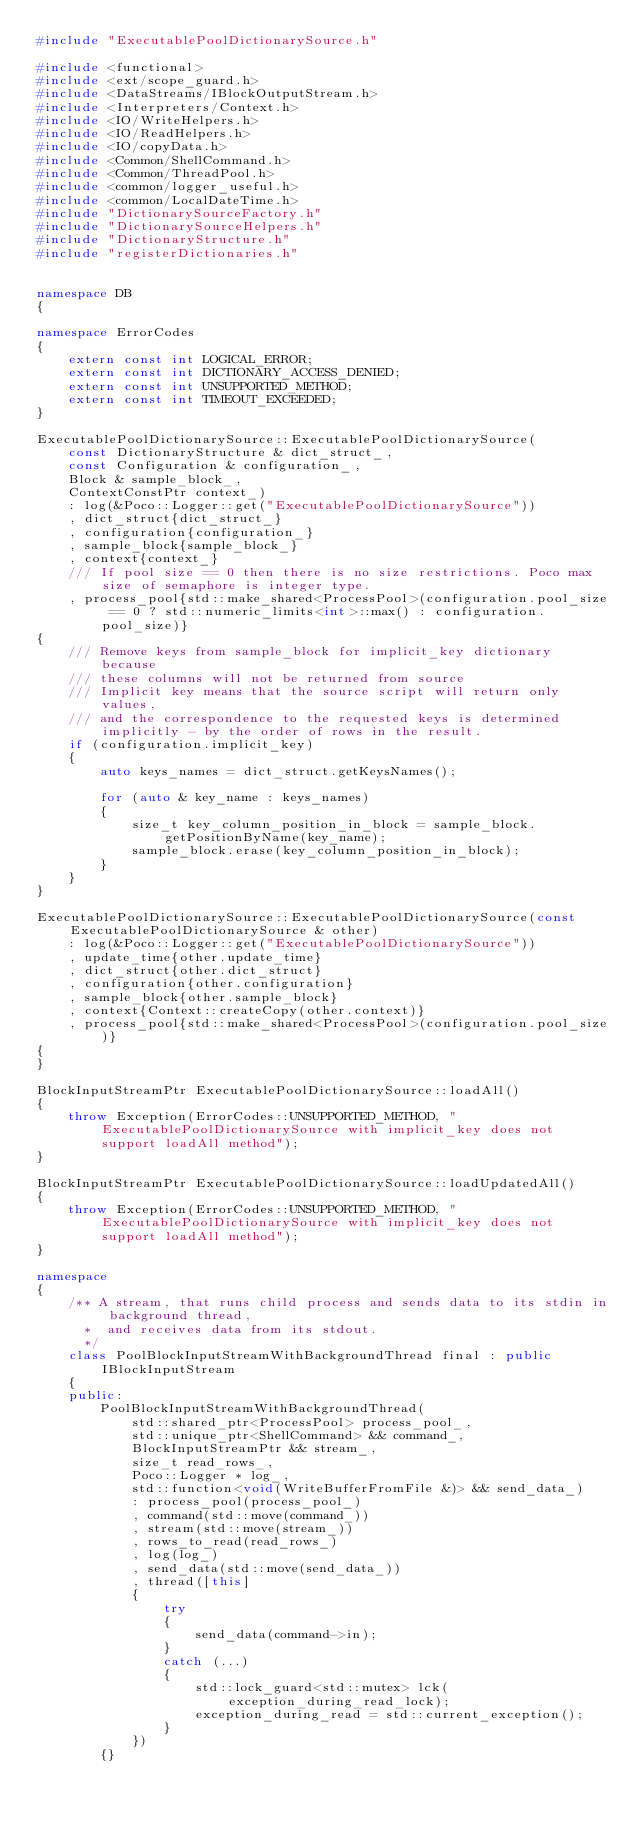Convert code to text. <code><loc_0><loc_0><loc_500><loc_500><_C++_>#include "ExecutablePoolDictionarySource.h"

#include <functional>
#include <ext/scope_guard.h>
#include <DataStreams/IBlockOutputStream.h>
#include <Interpreters/Context.h>
#include <IO/WriteHelpers.h>
#include <IO/ReadHelpers.h>
#include <IO/copyData.h>
#include <Common/ShellCommand.h>
#include <Common/ThreadPool.h>
#include <common/logger_useful.h>
#include <common/LocalDateTime.h>
#include "DictionarySourceFactory.h"
#include "DictionarySourceHelpers.h"
#include "DictionaryStructure.h"
#include "registerDictionaries.h"


namespace DB
{

namespace ErrorCodes
{
    extern const int LOGICAL_ERROR;
    extern const int DICTIONARY_ACCESS_DENIED;
    extern const int UNSUPPORTED_METHOD;
    extern const int TIMEOUT_EXCEEDED;
}

ExecutablePoolDictionarySource::ExecutablePoolDictionarySource(
    const DictionaryStructure & dict_struct_,
    const Configuration & configuration_,
    Block & sample_block_,
    ContextConstPtr context_)
    : log(&Poco::Logger::get("ExecutablePoolDictionarySource"))
    , dict_struct{dict_struct_}
    , configuration{configuration_}
    , sample_block{sample_block_}
    , context{context_}
    /// If pool size == 0 then there is no size restrictions. Poco max size of semaphore is integer type.
    , process_pool{std::make_shared<ProcessPool>(configuration.pool_size == 0 ? std::numeric_limits<int>::max() : configuration.pool_size)}
{
    /// Remove keys from sample_block for implicit_key dictionary because
    /// these columns will not be returned from source
    /// Implicit key means that the source script will return only values,
    /// and the correspondence to the requested keys is determined implicitly - by the order of rows in the result.
    if (configuration.implicit_key)
    {
        auto keys_names = dict_struct.getKeysNames();

        for (auto & key_name : keys_names)
        {
            size_t key_column_position_in_block = sample_block.getPositionByName(key_name);
            sample_block.erase(key_column_position_in_block);
        }
    }
}

ExecutablePoolDictionarySource::ExecutablePoolDictionarySource(const ExecutablePoolDictionarySource & other)
    : log(&Poco::Logger::get("ExecutablePoolDictionarySource"))
    , update_time{other.update_time}
    , dict_struct{other.dict_struct}
    , configuration{other.configuration}
    , sample_block{other.sample_block}
    , context{Context::createCopy(other.context)}
    , process_pool{std::make_shared<ProcessPool>(configuration.pool_size)}
{
}

BlockInputStreamPtr ExecutablePoolDictionarySource::loadAll()
{
    throw Exception(ErrorCodes::UNSUPPORTED_METHOD, "ExecutablePoolDictionarySource with implicit_key does not support loadAll method");
}

BlockInputStreamPtr ExecutablePoolDictionarySource::loadUpdatedAll()
{
    throw Exception(ErrorCodes::UNSUPPORTED_METHOD, "ExecutablePoolDictionarySource with implicit_key does not support loadAll method");
}

namespace
{
    /** A stream, that runs child process and sends data to its stdin in background thread,
      *  and receives data from its stdout.
      */
    class PoolBlockInputStreamWithBackgroundThread final : public IBlockInputStream
    {
    public:
        PoolBlockInputStreamWithBackgroundThread(
            std::shared_ptr<ProcessPool> process_pool_,
            std::unique_ptr<ShellCommand> && command_,
            BlockInputStreamPtr && stream_,
            size_t read_rows_,
            Poco::Logger * log_,
            std::function<void(WriteBufferFromFile &)> && send_data_)
            : process_pool(process_pool_)
            , command(std::move(command_))
            , stream(std::move(stream_))
            , rows_to_read(read_rows_)
            , log(log_)
            , send_data(std::move(send_data_))
            , thread([this]
            {
                try
                {
                    send_data(command->in);
                }
                catch (...)
                {
                    std::lock_guard<std::mutex> lck(exception_during_read_lock);
                    exception_during_read = std::current_exception();
                }
            })
        {}
</code> 